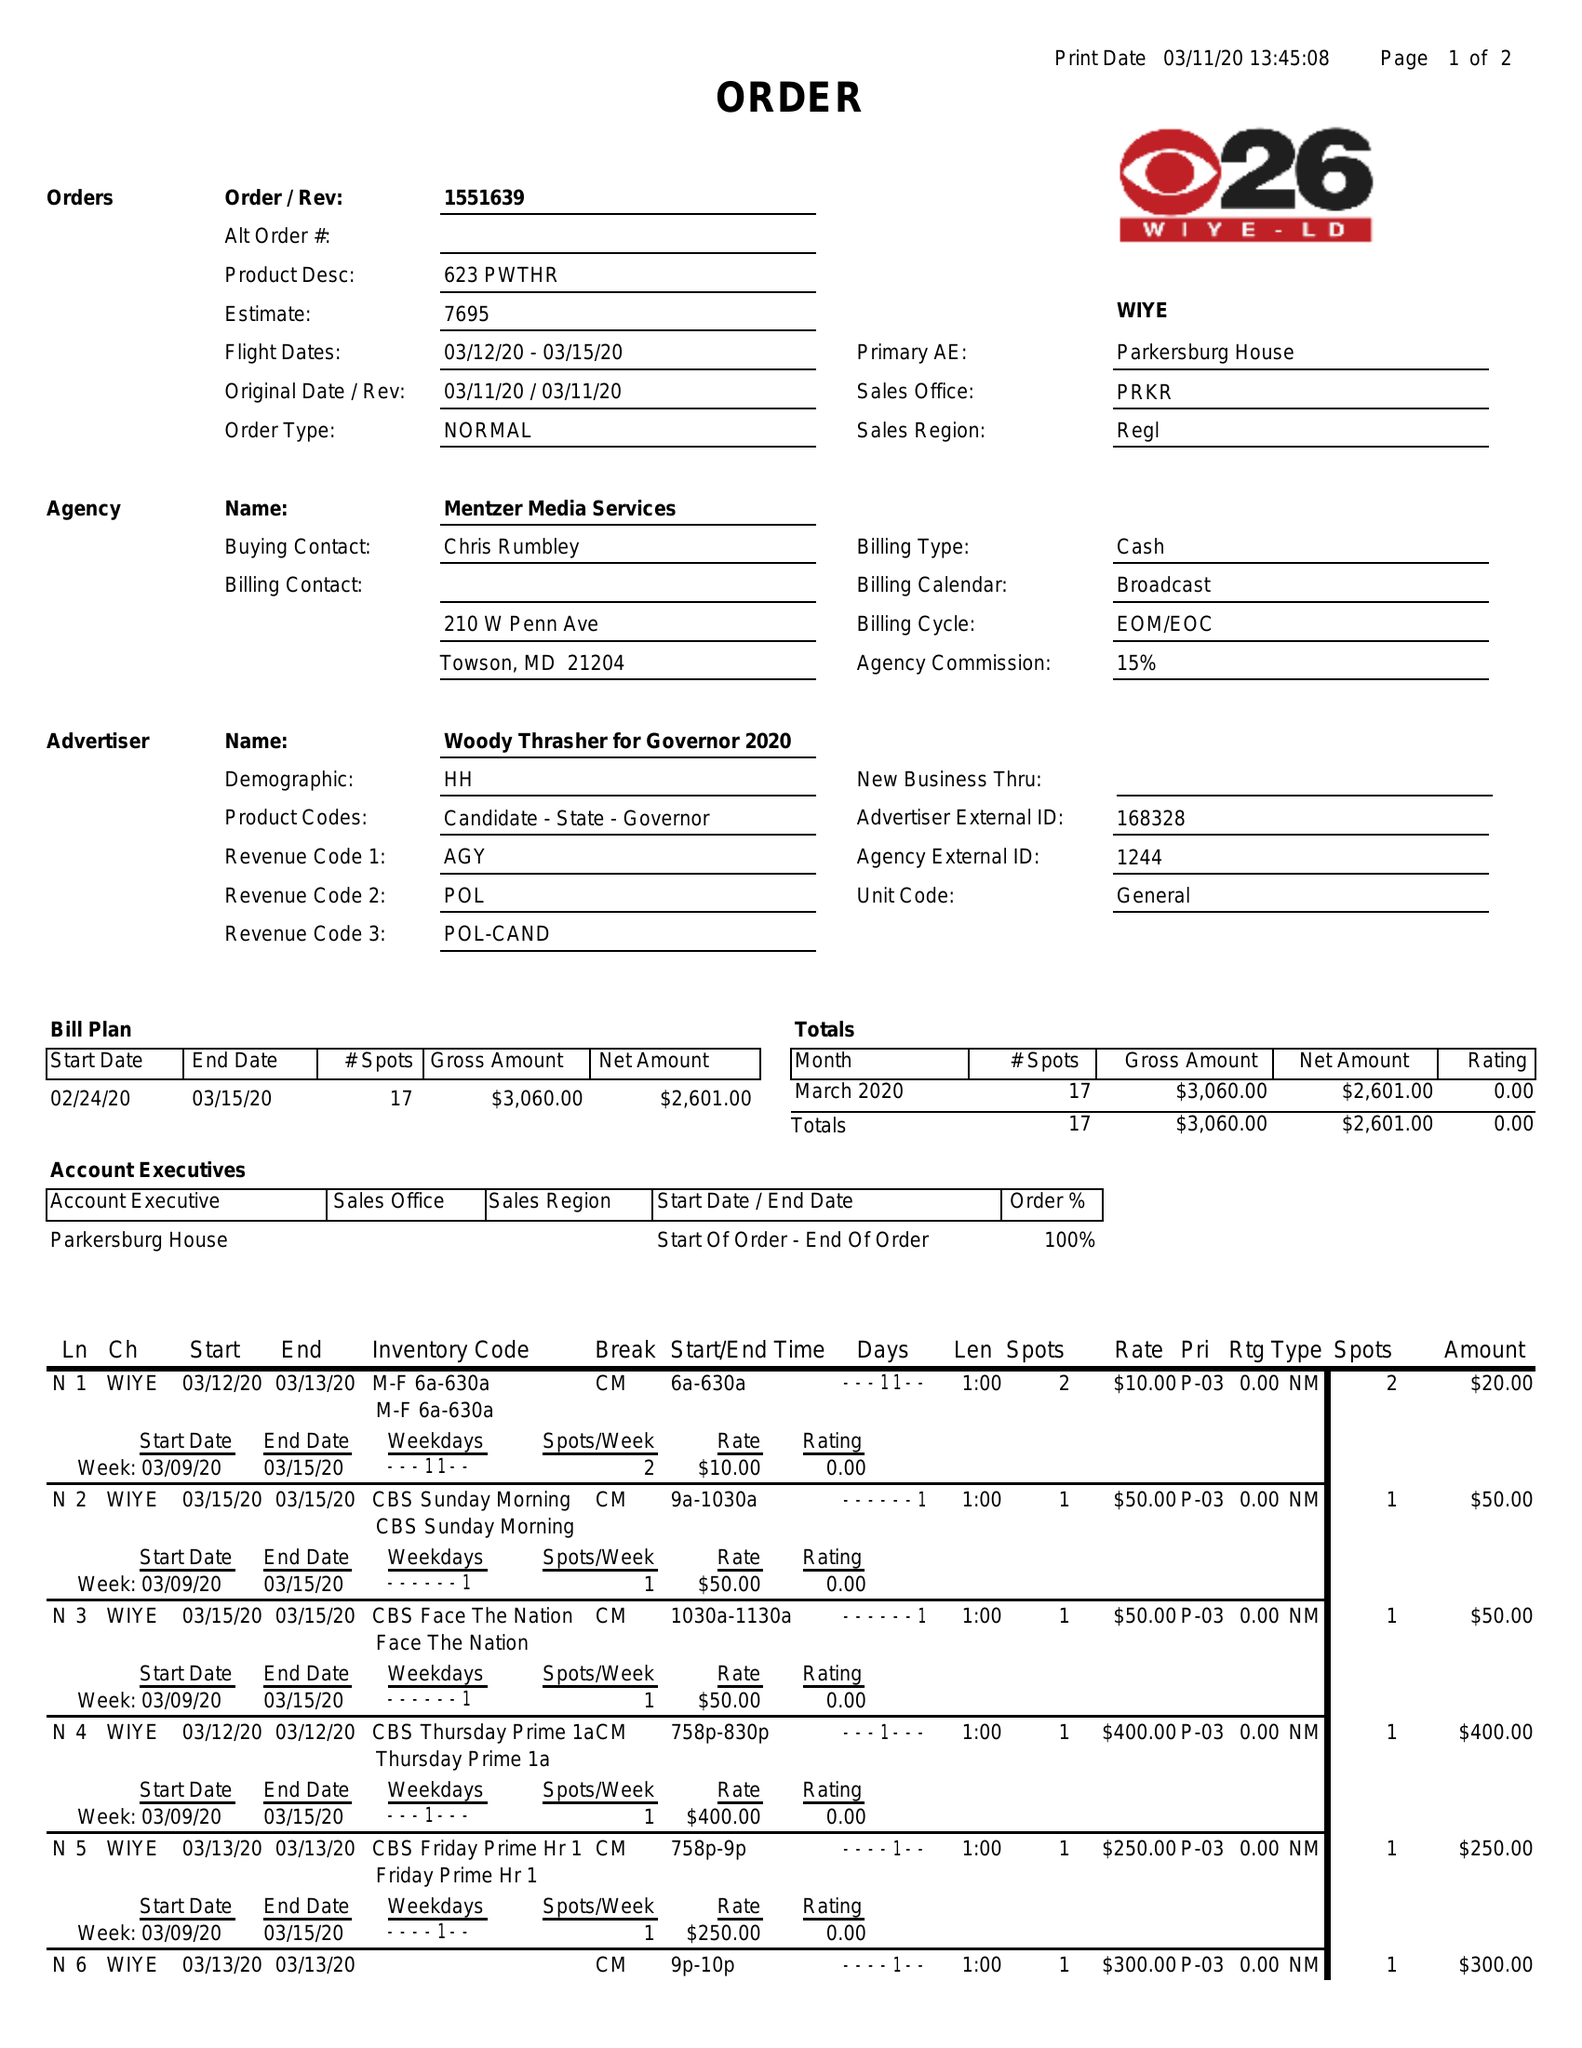What is the value for the flight_to?
Answer the question using a single word or phrase. 03/15/20 